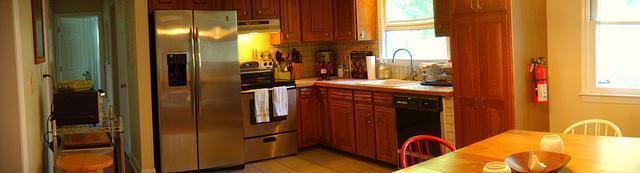How many red chairs are there?
Give a very brief answer. 1. How many dining tables can be seen?
Give a very brief answer. 1. How many men are sitting?
Give a very brief answer. 0. 